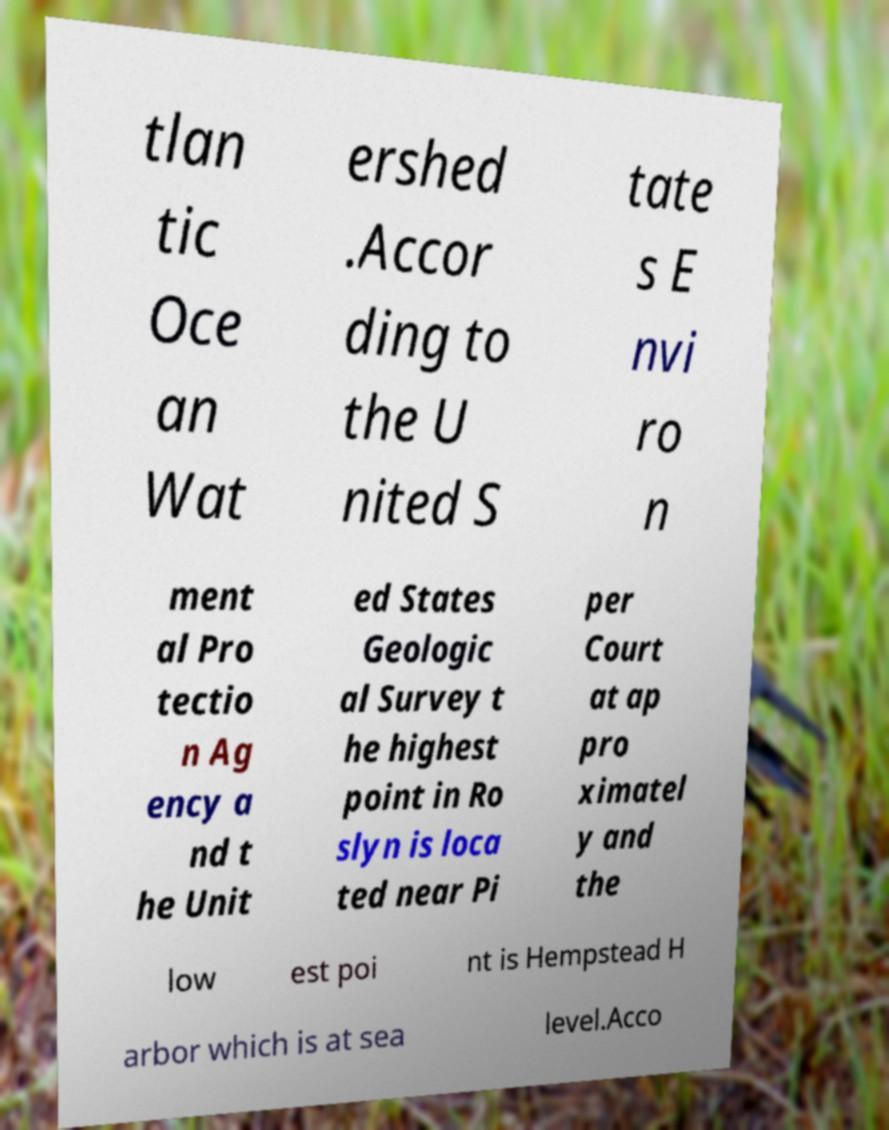Could you extract and type out the text from this image? tlan tic Oce an Wat ershed .Accor ding to the U nited S tate s E nvi ro n ment al Pro tectio n Ag ency a nd t he Unit ed States Geologic al Survey t he highest point in Ro slyn is loca ted near Pi per Court at ap pro ximatel y and the low est poi nt is Hempstead H arbor which is at sea level.Acco 